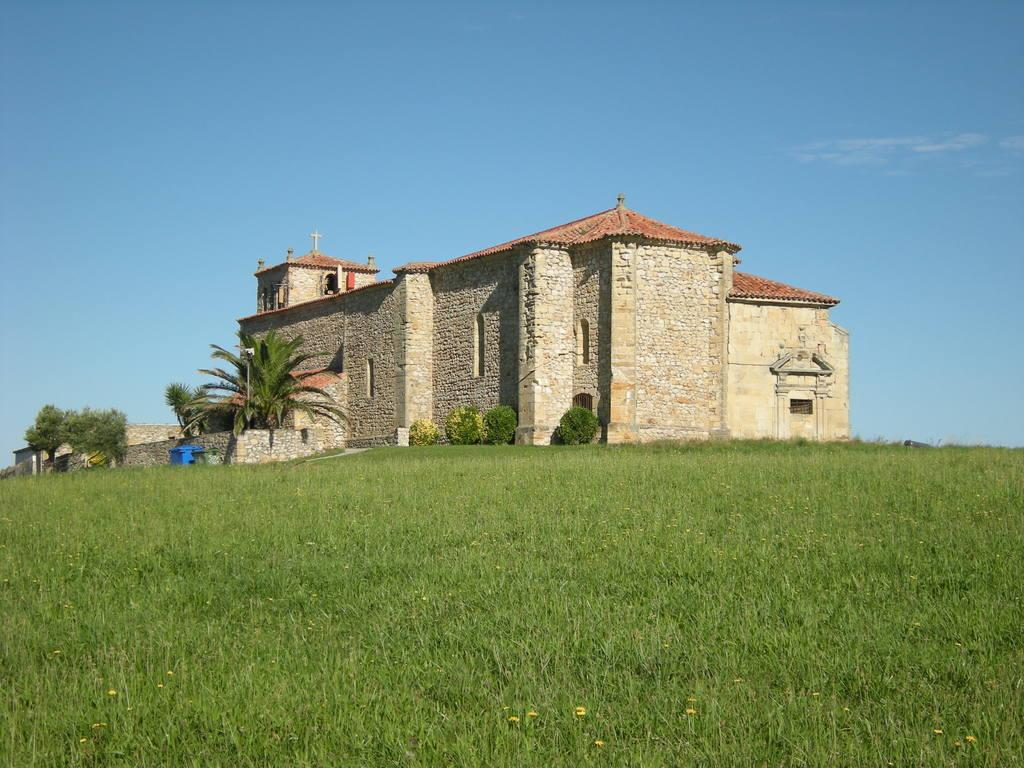What type of natural environment is visible at the bottom of the image? There is grass at the bottom of the image. What other natural elements can be seen in the image? There are trees and plants in the middle of the image. What type of structure is present in the image? There is a building in the middle of the image. What can be seen in the sky in the background of the image? There are clouds visible in the background of the image. What is the overall setting of the image? The image features a combination of natural elements, such as grass, trees, and plants, as well as a man-made structure, the building, and a sky with clouds. What type of game is being played on the sheet in the image? There is no sheet or game present in the image. 